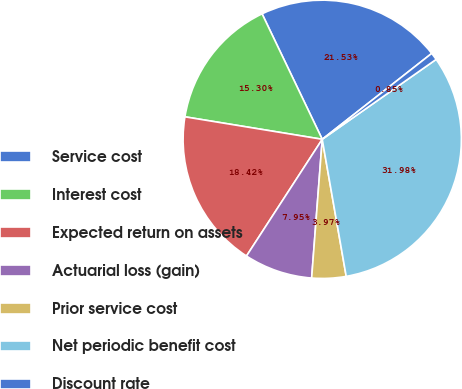Convert chart. <chart><loc_0><loc_0><loc_500><loc_500><pie_chart><fcel>Service cost<fcel>Interest cost<fcel>Expected return on assets<fcel>Actuarial loss (gain)<fcel>Prior service cost<fcel>Net periodic benefit cost<fcel>Discount rate<nl><fcel>21.53%<fcel>15.3%<fcel>18.42%<fcel>7.95%<fcel>3.97%<fcel>31.98%<fcel>0.85%<nl></chart> 